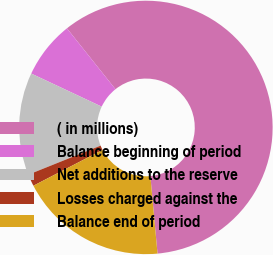Convert chart. <chart><loc_0><loc_0><loc_500><loc_500><pie_chart><fcel>( in millions)<fcel>Balance beginning of period<fcel>Net additions to the reserve<fcel>Losses charged against the<fcel>Balance end of period<nl><fcel>59.25%<fcel>7.3%<fcel>13.07%<fcel>1.53%<fcel>18.85%<nl></chart> 